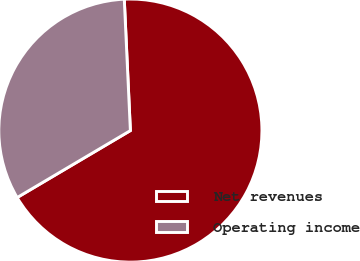Convert chart. <chart><loc_0><loc_0><loc_500><loc_500><pie_chart><fcel>Net revenues<fcel>Operating income<nl><fcel>67.24%<fcel>32.76%<nl></chart> 